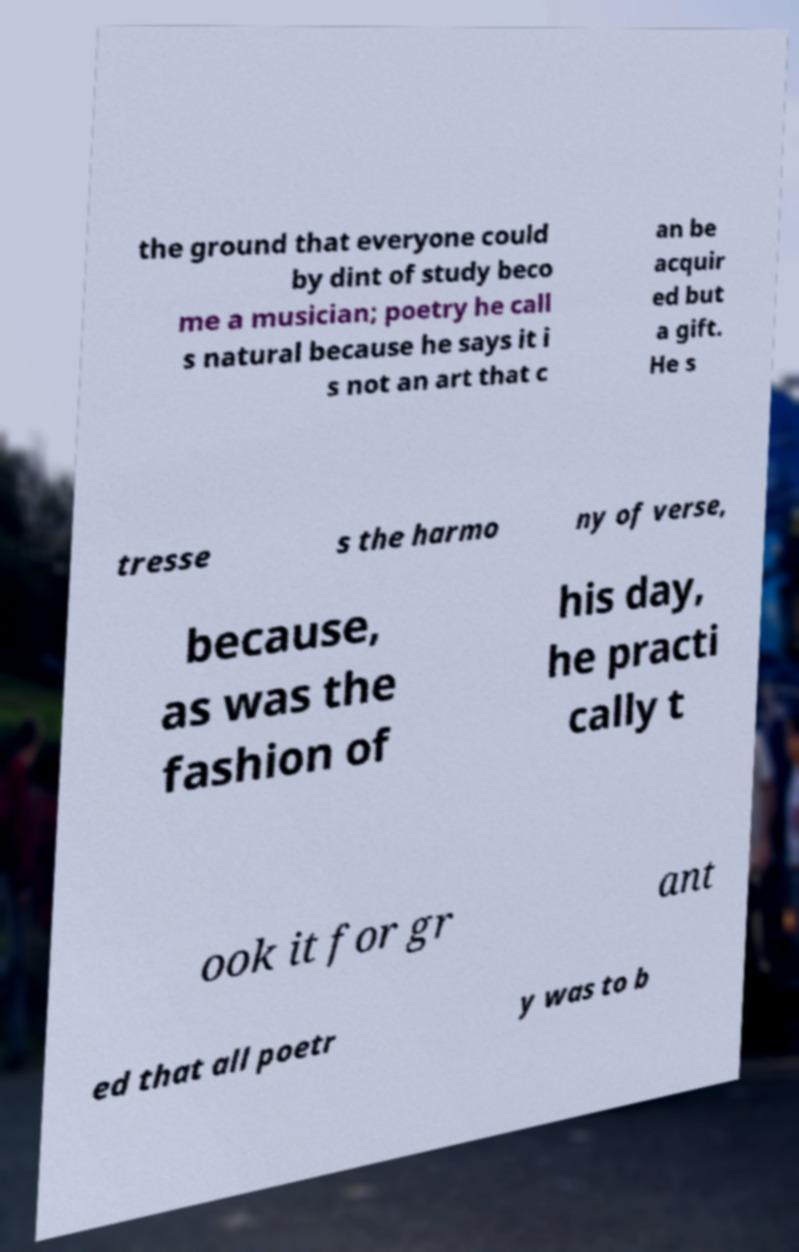Please identify and transcribe the text found in this image. the ground that everyone could by dint of study beco me a musician; poetry he call s natural because he says it i s not an art that c an be acquir ed but a gift. He s tresse s the harmo ny of verse, because, as was the fashion of his day, he practi cally t ook it for gr ant ed that all poetr y was to b 